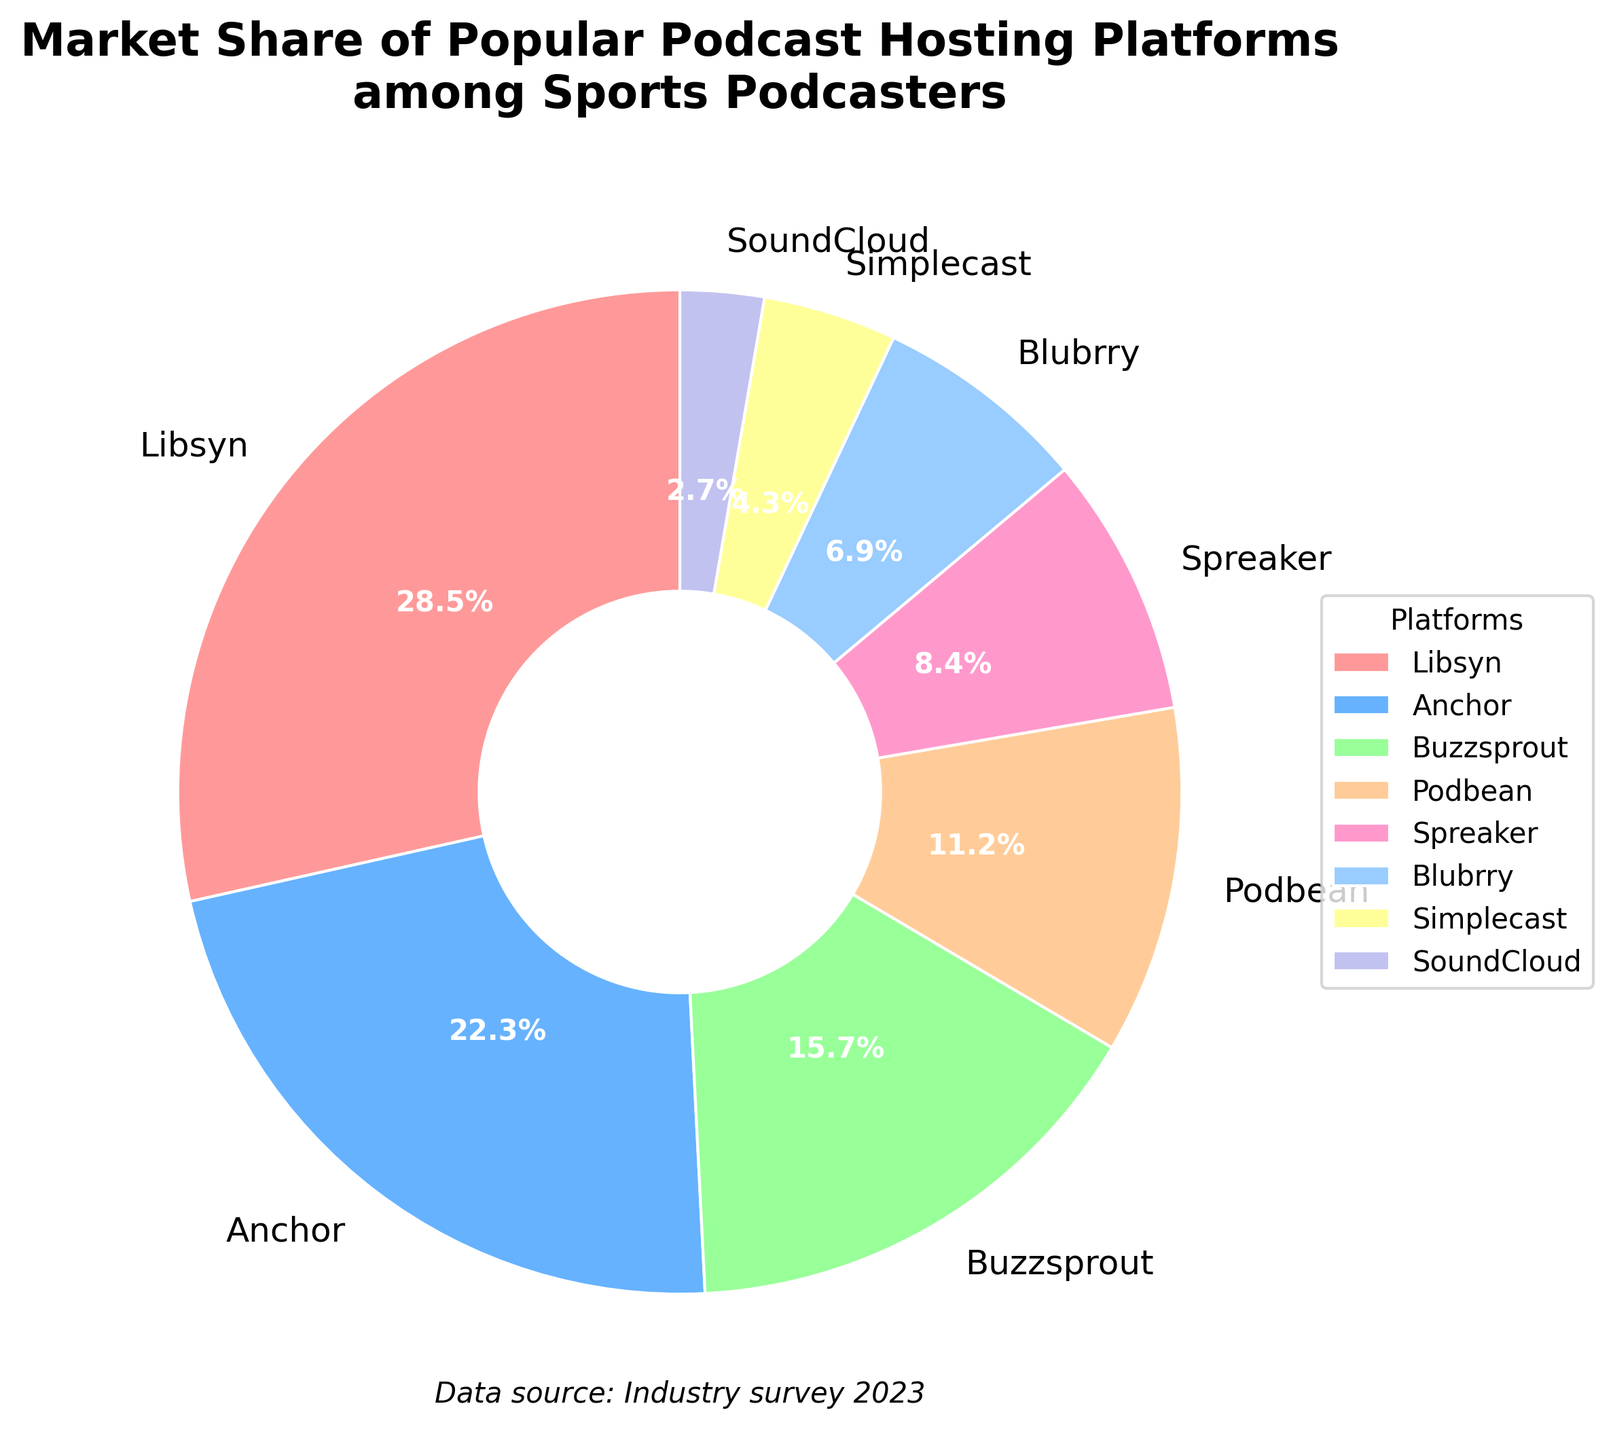What is the largest market share percentage among the podcast hosting platforms? The largest segment in the pie chart corresponds to Libsyn, which is labeled with a market share percentage of 28.5%.
Answer: 28.5% Which platform has the second-largest market share, and what is it? The pie chart shows that the segment labeled “Anchor” has the second-largest market share, which is 22.3%.
Answer: Anchor, 22.3% What is the combined market share of Libsyn and Anchor? Libsyn has 28.5% and Anchor has 22.3%. Summing these percentages gives 28.5 + 22.3 = 50.8%.
Answer: 50.8% How does the market share of Buzzsprout compare to Podbean? Buzzsprout has a market share of 15.7%, while Podbean has a market share of 11.2%. Buzzsprout’s market share is higher than Podbean’s.
Answer: Buzzsprout > Podbean Which platform has the smallest market share and what is the percentage? According to the pie chart, SoundCloud has the smallest market share at 2.7%.
Answer: SoundCloud, 2.7% What is the total market share of the platforms with less than 10% share individually? The platforms with less than 10% market share are Podbean (11.2%), Spreaker (8.4%), Blubrry (6.9%), Simplecast (4.3%), and SoundCloud (2.7%). Summing these up: 8.4 + 6.9 + 4.3 + 2.7 = 22.3%.
Answer: 22.3% Which platform is represented by the blue segment and what is its market share percentage? The blue segment in the pie chart corresponds to “Anchor” with a market share of 22.3%.
Answer: Anchor, 22.3% How much more market share does Libsyn have compared to Simplecast? Libsyn has a market share of 28.5%, and Simplecast has a market share of 4.3%. The difference is 28.5% - 4.3% = 24.2%.
Answer: 24.2% What is the average market share of Podbean, Spreaker, and Blubrry? Podbean has 11.2%, Spreaker has 8.4%, and Blubrry has 6.9%. Their combined market share is 11.2 + 8.4 + 6.9 = 26.5%. Dividing by 3 to get the average: 26.5 / 3 ≈ 8.83%.
Answer: 8.83% Create a comparative question involving three platforms other than the top two market share holders and provide the reasoning steps necessary to answer it. Example question: Among Buzzsprout, Podbean, and Spreaker, which two combined have a higher market share than the third? Buzzsprout has 15.7%, Podbean has 11.2%, and Spreaker has 8.4%. We will compare the sum of each pair to the remaining one: (15.7 + 11.2 = 26.9) > 8.4, (15.7 + 8.4 = 24.1) > 11.2, and (11.2 + 8.4 = 19.6) > 15.7. All combinations are higher than the third, thus any two combined are higher than the remaining one.
Answer: Any two combined are higher than the third 